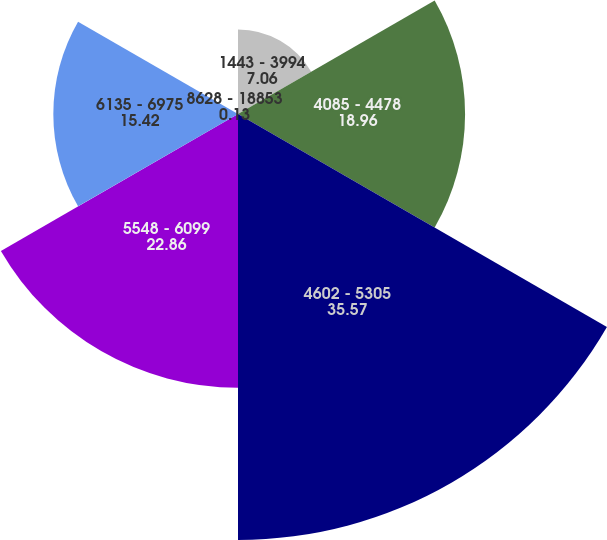Convert chart to OTSL. <chart><loc_0><loc_0><loc_500><loc_500><pie_chart><fcel>1443 - 3994<fcel>4085 - 4478<fcel>4602 - 5305<fcel>5548 - 6099<fcel>6135 - 6975<fcel>8628 - 18853<nl><fcel>7.06%<fcel>18.96%<fcel>35.57%<fcel>22.86%<fcel>15.42%<fcel>0.13%<nl></chart> 